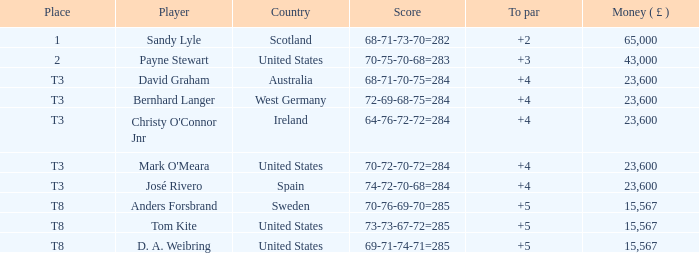What place is David Graham in? T3. 